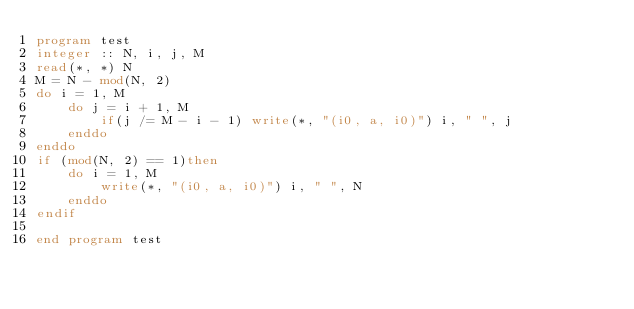Convert code to text. <code><loc_0><loc_0><loc_500><loc_500><_FORTRAN_>program test
integer :: N, i, j, M
read(*, *) N
M = N - mod(N, 2)
do i = 1, M
    do j = i + 1, M
        if(j /= M - i - 1) write(*, "(i0, a, i0)") i, " ", j
    enddo 
enddo
if (mod(N, 2) == 1)then
    do i = 1, M
        write(*, "(i0, a, i0)") i, " ", N
    enddo 
endif

end program test</code> 